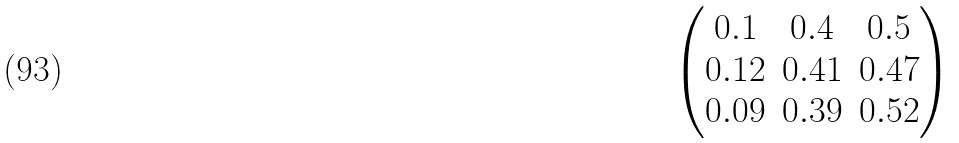Convert formula to latex. <formula><loc_0><loc_0><loc_500><loc_500>\left ( \begin{matrix} 0 . 1 & 0 . 4 & 0 . 5 \\ 0 . 1 2 & 0 . 4 1 & 0 . 4 7 \\ 0 . 0 9 & 0 . 3 9 & 0 . 5 2 \end{matrix} \right )</formula> 